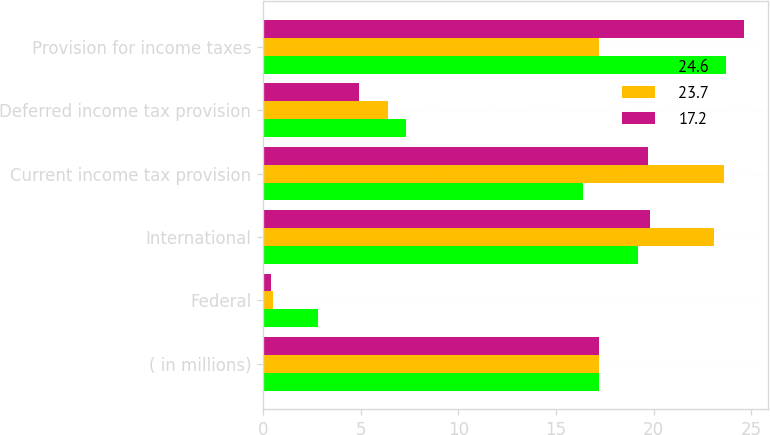<chart> <loc_0><loc_0><loc_500><loc_500><stacked_bar_chart><ecel><fcel>( in millions)<fcel>Federal<fcel>International<fcel>Current income tax provision<fcel>Deferred income tax provision<fcel>Provision for income taxes<nl><fcel>24.6<fcel>17.2<fcel>2.8<fcel>19.2<fcel>16.4<fcel>7.3<fcel>23.7<nl><fcel>23.7<fcel>17.2<fcel>0.5<fcel>23.1<fcel>23.6<fcel>6.4<fcel>17.2<nl><fcel>17.2<fcel>17.2<fcel>0.4<fcel>19.8<fcel>19.7<fcel>4.9<fcel>24.6<nl></chart> 